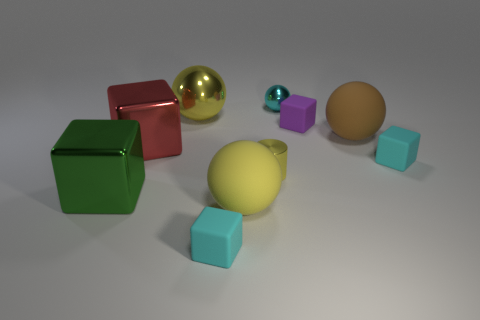Subtract all large metallic spheres. How many spheres are left? 3 Subtract all green cubes. How many cubes are left? 4 Subtract all red cubes. Subtract all blue spheres. How many cubes are left? 4 Subtract all cylinders. How many objects are left? 9 Add 3 cyan cubes. How many cyan cubes exist? 5 Subtract 0 green cylinders. How many objects are left? 10 Subtract all large gray things. Subtract all big brown balls. How many objects are left? 9 Add 5 yellow cylinders. How many yellow cylinders are left? 6 